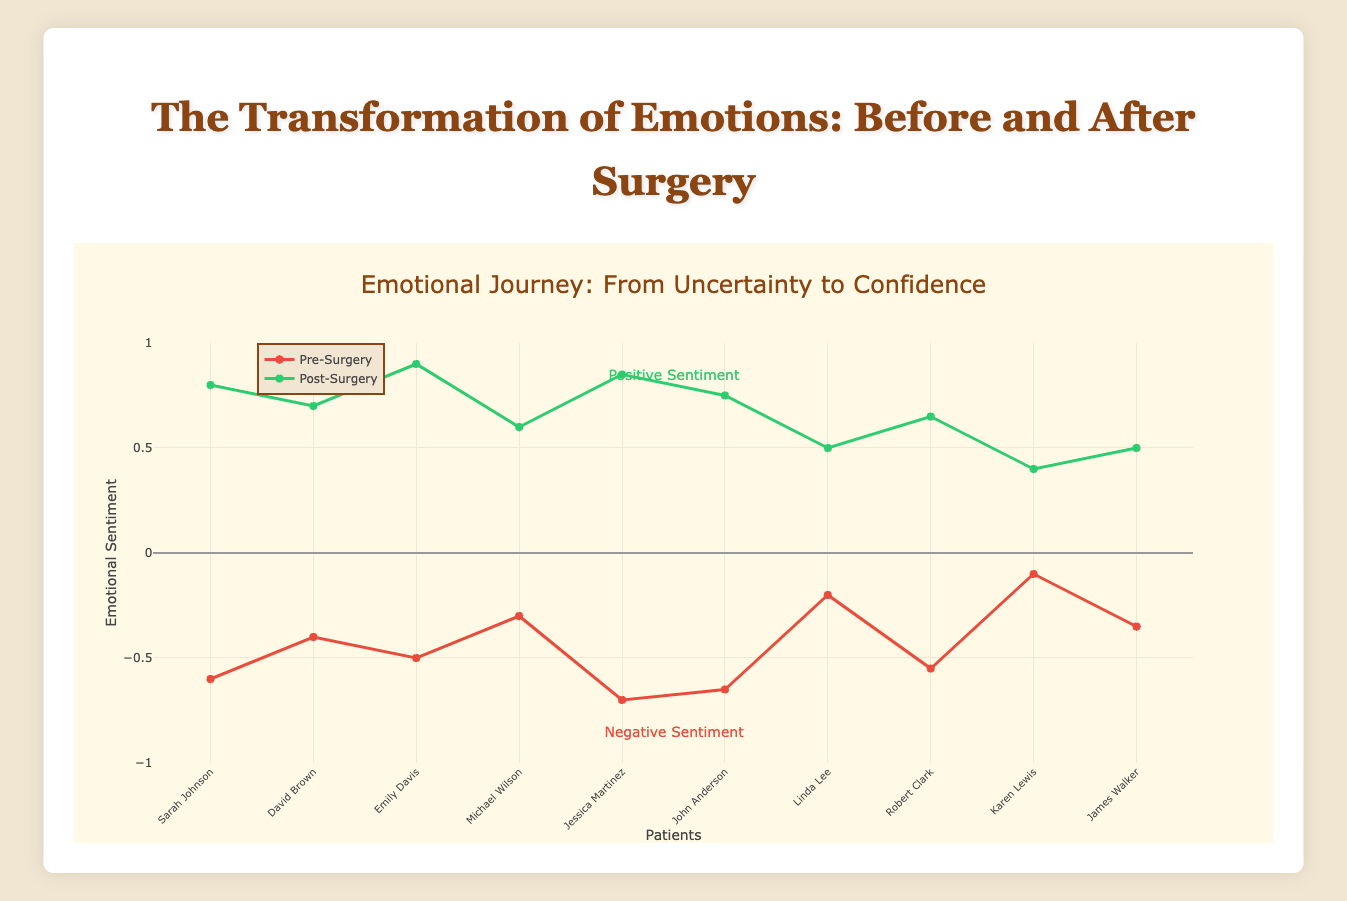What is the average post-surgery sentiment among all patients? To find the average post-surgery sentiment, sum all the post-surgery sentiment values and divide by the number of patients. The total sum is 7.15, and there are 10 patients. Thus, the average is 7.15 / 10 = 0.715.
Answer: 0.715 Which patient had the largest increase in emotional sentiment post-surgery? Calculate the increase in sentiment by subtracting each patient's pre-surgery sentiment from their post-surgery sentiment. The patient with the largest increase is Jessica Martinez with an increase of 1.55 (0.85 - (-0.7)).
Answer: Jessica Martinez How does the emotional sentiment change for patients who underwent facial surgeries (Rhinoplasty, Facelift, Blepharoplasty, and Chin Augmentation) compare to those who underwent body surgeries (Liposuction, Breast Augmentation, Tummy Tuck, Gynecomastia Surgery)? Calculate the average pre and post-surgery sentiments for facial and body surgeries. Facial surgeries: [(0.8 - (-0.6)) + (0.6 - (-0.3)) + (0.5 - (-0.2)) + (0.5 - (-0.35))]/4 = 0.875. Body surgeries: [(0.7 - (-0.4)) + (0.9 - (-0.5)) + (0.85 - (-0.7)) + (0.75 - (-0.65))]/4 = 1.25. The sentiment increase for facial surgeries is 0.875, and for body surgeries, it is 1.25.
Answer: Body surgeries have a larger sentiment increase Identify patients whose pre-surgery sentiment was below -0.5 but improved to above 0.6 post-surgery. Check patient sentiment values: Sarah Johnson (-0.6 to 0.8), Emily Davis (-0.5 to 0.9), Jessica Martinez (-0.7 to 0.85), John Anderson (-0.65 to 0.75). Only Sarah Johnson, Jessica Martinez, and John Anderson fit the criteria.
Answer: Sarah Johnson, Jessica Martinez, John Anderson Is there a common color pattern used to distinguish pre-surgery and post-surgery sentiment lines? The plot uses red lines for pre-surgery sentiment and green lines for post-surgery sentiment, indicating negative and positive changes in emotional sentiment, respectively.
Answer: Red for pre-surgery, green for post-surgery What is the range of pre-surgery sentiments observed in the data? The minimum pre-surgery sentiment is -0.7 (Jessica Martinez), and the maximum is -0.1 (Karen Lewis). The range is the difference: -0.1 - (-0.7) = 0.6.
Answer: 0.6 Which patient has the lowest post-surgery sentiment, and what was their initial sentiment? The lowest post-surgery sentiment is 0.4 (Karen Lewis), whose initial sentiment was -0.1.
Answer: Karen Lewis, -0.1 How many patients show a post-surgery sentiment above 0.75? Count the number of patients with post-surgery sentiment above 0.75: Sarah Johnson (0.8), Emily Davis (0.9), Jessica Martinez (0.85), John Anderson (0.75). Thus, 4 patients have a sentiment above 0.75.
Answer: 4 Who experienced the least change in emotional sentiment post-surgery? Calculate the change for each patient. Linda Lee exhibits the smallest sentiment change of 0.7 (0.5 - (-0.2)).
Answer: Linda Lee 